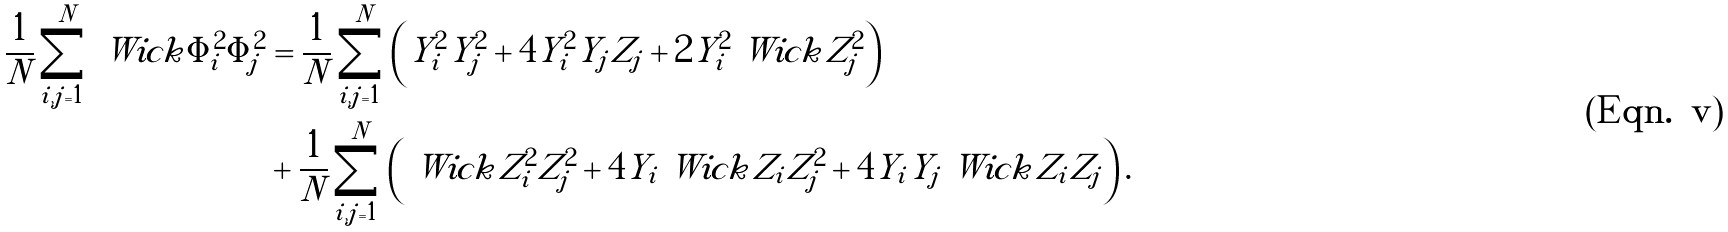Convert formula to latex. <formula><loc_0><loc_0><loc_500><loc_500>\frac { 1 } { N } \sum _ { i , j = 1 } ^ { N } \ W i c k { \Phi _ { i } ^ { 2 } \Phi _ { j } ^ { 2 } } & = \frac { 1 } { N } \sum _ { i , j = 1 } ^ { N } \left ( Y _ { i } ^ { 2 } Y _ { j } ^ { 2 } + 4 Y _ { i } ^ { 2 } Y _ { j } Z _ { j } + 2 Y _ { i } ^ { 2 } \ W i c k { Z _ { j } ^ { 2 } } \right ) \\ & + \frac { 1 } { N } \sum _ { i , j = 1 } ^ { N } \left ( \ W i c k { Z _ { i } ^ { 2 } Z _ { j } ^ { 2 } } + 4 Y _ { i } \ W i c k { Z _ { i } Z _ { j } ^ { 2 } } + 4 Y _ { i } Y _ { j } \ W i c k { Z _ { i } Z _ { j } } \right ) .</formula> 